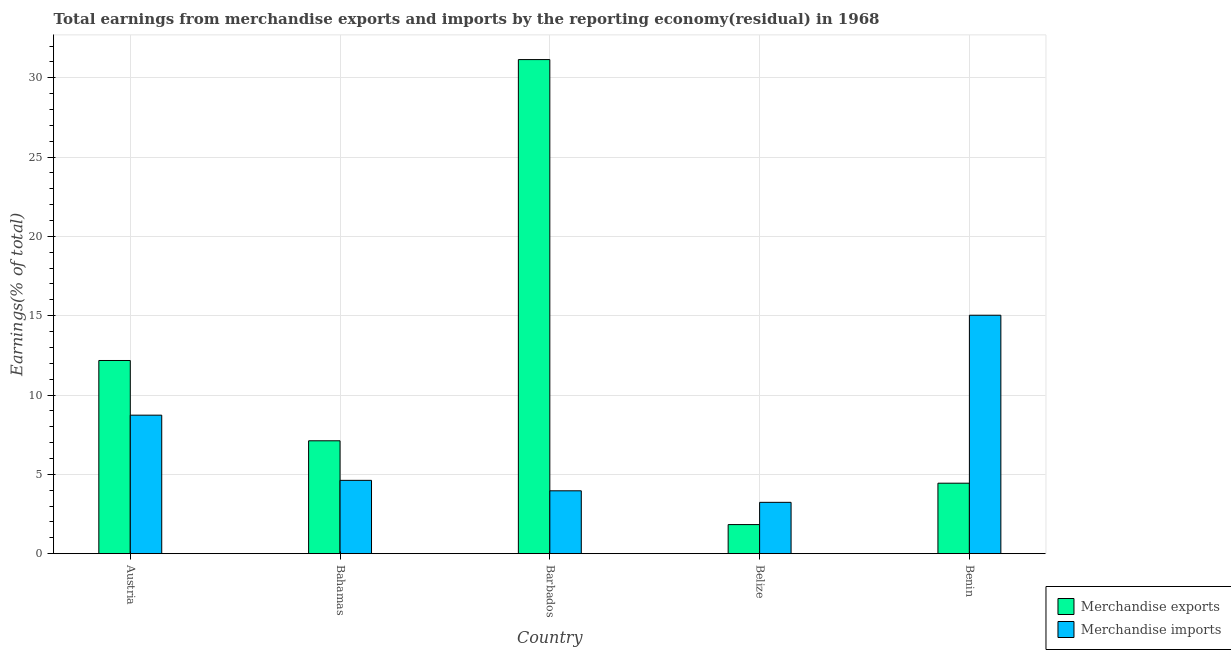Are the number of bars per tick equal to the number of legend labels?
Offer a very short reply. Yes. Are the number of bars on each tick of the X-axis equal?
Offer a terse response. Yes. How many bars are there on the 1st tick from the right?
Give a very brief answer. 2. What is the label of the 5th group of bars from the left?
Your answer should be very brief. Benin. What is the earnings from merchandise imports in Belize?
Give a very brief answer. 3.23. Across all countries, what is the maximum earnings from merchandise exports?
Keep it short and to the point. 31.15. Across all countries, what is the minimum earnings from merchandise exports?
Your answer should be compact. 1.83. In which country was the earnings from merchandise exports maximum?
Provide a short and direct response. Barbados. In which country was the earnings from merchandise exports minimum?
Provide a succinct answer. Belize. What is the total earnings from merchandise imports in the graph?
Your response must be concise. 35.58. What is the difference between the earnings from merchandise imports in Bahamas and that in Barbados?
Give a very brief answer. 0.66. What is the difference between the earnings from merchandise exports in Bahamas and the earnings from merchandise imports in Benin?
Ensure brevity in your answer.  -7.92. What is the average earnings from merchandise exports per country?
Provide a short and direct response. 11.34. What is the difference between the earnings from merchandise imports and earnings from merchandise exports in Benin?
Offer a terse response. 10.59. What is the ratio of the earnings from merchandise imports in Bahamas to that in Belize?
Make the answer very short. 1.43. Is the earnings from merchandise imports in Bahamas less than that in Benin?
Keep it short and to the point. Yes. Is the difference between the earnings from merchandise exports in Austria and Belize greater than the difference between the earnings from merchandise imports in Austria and Belize?
Your answer should be compact. Yes. What is the difference between the highest and the second highest earnings from merchandise imports?
Your answer should be compact. 6.3. What is the difference between the highest and the lowest earnings from merchandise exports?
Offer a terse response. 29.32. In how many countries, is the earnings from merchandise exports greater than the average earnings from merchandise exports taken over all countries?
Provide a succinct answer. 2. Is the sum of the earnings from merchandise exports in Austria and Barbados greater than the maximum earnings from merchandise imports across all countries?
Your answer should be compact. Yes. How many bars are there?
Offer a very short reply. 10. Are all the bars in the graph horizontal?
Your answer should be compact. No. How many countries are there in the graph?
Provide a succinct answer. 5. Does the graph contain any zero values?
Offer a very short reply. No. Does the graph contain grids?
Ensure brevity in your answer.  Yes. Where does the legend appear in the graph?
Provide a short and direct response. Bottom right. What is the title of the graph?
Your answer should be compact. Total earnings from merchandise exports and imports by the reporting economy(residual) in 1968. Does "Urban" appear as one of the legend labels in the graph?
Make the answer very short. No. What is the label or title of the X-axis?
Make the answer very short. Country. What is the label or title of the Y-axis?
Provide a short and direct response. Earnings(% of total). What is the Earnings(% of total) of Merchandise exports in Austria?
Give a very brief answer. 12.18. What is the Earnings(% of total) in Merchandise imports in Austria?
Your answer should be compact. 8.73. What is the Earnings(% of total) of Merchandise exports in Bahamas?
Offer a terse response. 7.11. What is the Earnings(% of total) of Merchandise imports in Bahamas?
Keep it short and to the point. 4.62. What is the Earnings(% of total) in Merchandise exports in Barbados?
Your answer should be compact. 31.15. What is the Earnings(% of total) of Merchandise imports in Barbados?
Offer a very short reply. 3.96. What is the Earnings(% of total) in Merchandise exports in Belize?
Offer a very short reply. 1.83. What is the Earnings(% of total) of Merchandise imports in Belize?
Ensure brevity in your answer.  3.23. What is the Earnings(% of total) in Merchandise exports in Benin?
Make the answer very short. 4.44. What is the Earnings(% of total) of Merchandise imports in Benin?
Offer a very short reply. 15.03. Across all countries, what is the maximum Earnings(% of total) of Merchandise exports?
Your answer should be very brief. 31.15. Across all countries, what is the maximum Earnings(% of total) of Merchandise imports?
Ensure brevity in your answer.  15.03. Across all countries, what is the minimum Earnings(% of total) in Merchandise exports?
Your answer should be compact. 1.83. Across all countries, what is the minimum Earnings(% of total) of Merchandise imports?
Your answer should be very brief. 3.23. What is the total Earnings(% of total) of Merchandise exports in the graph?
Your answer should be compact. 56.71. What is the total Earnings(% of total) in Merchandise imports in the graph?
Offer a very short reply. 35.58. What is the difference between the Earnings(% of total) in Merchandise exports in Austria and that in Bahamas?
Make the answer very short. 5.06. What is the difference between the Earnings(% of total) of Merchandise imports in Austria and that in Bahamas?
Keep it short and to the point. 4.11. What is the difference between the Earnings(% of total) of Merchandise exports in Austria and that in Barbados?
Offer a very short reply. -18.97. What is the difference between the Earnings(% of total) in Merchandise imports in Austria and that in Barbados?
Make the answer very short. 4.77. What is the difference between the Earnings(% of total) in Merchandise exports in Austria and that in Belize?
Ensure brevity in your answer.  10.34. What is the difference between the Earnings(% of total) of Merchandise imports in Austria and that in Belize?
Ensure brevity in your answer.  5.49. What is the difference between the Earnings(% of total) of Merchandise exports in Austria and that in Benin?
Provide a short and direct response. 7.73. What is the difference between the Earnings(% of total) of Merchandise imports in Austria and that in Benin?
Provide a succinct answer. -6.3. What is the difference between the Earnings(% of total) of Merchandise exports in Bahamas and that in Barbados?
Make the answer very short. -24.03. What is the difference between the Earnings(% of total) of Merchandise imports in Bahamas and that in Barbados?
Offer a very short reply. 0.66. What is the difference between the Earnings(% of total) of Merchandise exports in Bahamas and that in Belize?
Offer a very short reply. 5.28. What is the difference between the Earnings(% of total) in Merchandise imports in Bahamas and that in Belize?
Keep it short and to the point. 1.39. What is the difference between the Earnings(% of total) in Merchandise exports in Bahamas and that in Benin?
Offer a very short reply. 2.67. What is the difference between the Earnings(% of total) of Merchandise imports in Bahamas and that in Benin?
Your response must be concise. -10.41. What is the difference between the Earnings(% of total) in Merchandise exports in Barbados and that in Belize?
Give a very brief answer. 29.32. What is the difference between the Earnings(% of total) in Merchandise imports in Barbados and that in Belize?
Your answer should be very brief. 0.73. What is the difference between the Earnings(% of total) in Merchandise exports in Barbados and that in Benin?
Offer a very short reply. 26.71. What is the difference between the Earnings(% of total) of Merchandise imports in Barbados and that in Benin?
Your response must be concise. -11.07. What is the difference between the Earnings(% of total) in Merchandise exports in Belize and that in Benin?
Your response must be concise. -2.61. What is the difference between the Earnings(% of total) of Merchandise imports in Belize and that in Benin?
Keep it short and to the point. -11.8. What is the difference between the Earnings(% of total) in Merchandise exports in Austria and the Earnings(% of total) in Merchandise imports in Bahamas?
Your response must be concise. 7.56. What is the difference between the Earnings(% of total) in Merchandise exports in Austria and the Earnings(% of total) in Merchandise imports in Barbados?
Offer a very short reply. 8.21. What is the difference between the Earnings(% of total) of Merchandise exports in Austria and the Earnings(% of total) of Merchandise imports in Belize?
Provide a short and direct response. 8.94. What is the difference between the Earnings(% of total) in Merchandise exports in Austria and the Earnings(% of total) in Merchandise imports in Benin?
Provide a succinct answer. -2.85. What is the difference between the Earnings(% of total) of Merchandise exports in Bahamas and the Earnings(% of total) of Merchandise imports in Barbados?
Provide a succinct answer. 3.15. What is the difference between the Earnings(% of total) of Merchandise exports in Bahamas and the Earnings(% of total) of Merchandise imports in Belize?
Offer a very short reply. 3.88. What is the difference between the Earnings(% of total) of Merchandise exports in Bahamas and the Earnings(% of total) of Merchandise imports in Benin?
Your answer should be compact. -7.92. What is the difference between the Earnings(% of total) of Merchandise exports in Barbados and the Earnings(% of total) of Merchandise imports in Belize?
Provide a succinct answer. 27.91. What is the difference between the Earnings(% of total) in Merchandise exports in Barbados and the Earnings(% of total) in Merchandise imports in Benin?
Keep it short and to the point. 16.12. What is the difference between the Earnings(% of total) in Merchandise exports in Belize and the Earnings(% of total) in Merchandise imports in Benin?
Provide a short and direct response. -13.2. What is the average Earnings(% of total) in Merchandise exports per country?
Provide a short and direct response. 11.34. What is the average Earnings(% of total) of Merchandise imports per country?
Offer a terse response. 7.12. What is the difference between the Earnings(% of total) of Merchandise exports and Earnings(% of total) of Merchandise imports in Austria?
Keep it short and to the point. 3.45. What is the difference between the Earnings(% of total) of Merchandise exports and Earnings(% of total) of Merchandise imports in Bahamas?
Provide a succinct answer. 2.49. What is the difference between the Earnings(% of total) in Merchandise exports and Earnings(% of total) in Merchandise imports in Barbados?
Ensure brevity in your answer.  27.19. What is the difference between the Earnings(% of total) in Merchandise exports and Earnings(% of total) in Merchandise imports in Belize?
Provide a short and direct response. -1.4. What is the difference between the Earnings(% of total) in Merchandise exports and Earnings(% of total) in Merchandise imports in Benin?
Provide a short and direct response. -10.59. What is the ratio of the Earnings(% of total) of Merchandise exports in Austria to that in Bahamas?
Your answer should be very brief. 1.71. What is the ratio of the Earnings(% of total) of Merchandise imports in Austria to that in Bahamas?
Offer a very short reply. 1.89. What is the ratio of the Earnings(% of total) of Merchandise exports in Austria to that in Barbados?
Your answer should be compact. 0.39. What is the ratio of the Earnings(% of total) in Merchandise imports in Austria to that in Barbados?
Your response must be concise. 2.2. What is the ratio of the Earnings(% of total) of Merchandise exports in Austria to that in Belize?
Make the answer very short. 6.65. What is the ratio of the Earnings(% of total) in Merchandise imports in Austria to that in Belize?
Offer a terse response. 2.7. What is the ratio of the Earnings(% of total) in Merchandise exports in Austria to that in Benin?
Keep it short and to the point. 2.74. What is the ratio of the Earnings(% of total) of Merchandise imports in Austria to that in Benin?
Keep it short and to the point. 0.58. What is the ratio of the Earnings(% of total) of Merchandise exports in Bahamas to that in Barbados?
Offer a terse response. 0.23. What is the ratio of the Earnings(% of total) in Merchandise imports in Bahamas to that in Barbados?
Keep it short and to the point. 1.17. What is the ratio of the Earnings(% of total) of Merchandise exports in Bahamas to that in Belize?
Keep it short and to the point. 3.88. What is the ratio of the Earnings(% of total) of Merchandise imports in Bahamas to that in Belize?
Make the answer very short. 1.43. What is the ratio of the Earnings(% of total) of Merchandise exports in Bahamas to that in Benin?
Provide a succinct answer. 1.6. What is the ratio of the Earnings(% of total) in Merchandise imports in Bahamas to that in Benin?
Keep it short and to the point. 0.31. What is the ratio of the Earnings(% of total) in Merchandise exports in Barbados to that in Belize?
Your answer should be compact. 17. What is the ratio of the Earnings(% of total) of Merchandise imports in Barbados to that in Belize?
Give a very brief answer. 1.22. What is the ratio of the Earnings(% of total) of Merchandise exports in Barbados to that in Benin?
Give a very brief answer. 7.01. What is the ratio of the Earnings(% of total) in Merchandise imports in Barbados to that in Benin?
Your answer should be very brief. 0.26. What is the ratio of the Earnings(% of total) in Merchandise exports in Belize to that in Benin?
Make the answer very short. 0.41. What is the ratio of the Earnings(% of total) in Merchandise imports in Belize to that in Benin?
Keep it short and to the point. 0.22. What is the difference between the highest and the second highest Earnings(% of total) in Merchandise exports?
Provide a short and direct response. 18.97. What is the difference between the highest and the second highest Earnings(% of total) in Merchandise imports?
Ensure brevity in your answer.  6.3. What is the difference between the highest and the lowest Earnings(% of total) of Merchandise exports?
Provide a short and direct response. 29.32. What is the difference between the highest and the lowest Earnings(% of total) in Merchandise imports?
Provide a succinct answer. 11.8. 